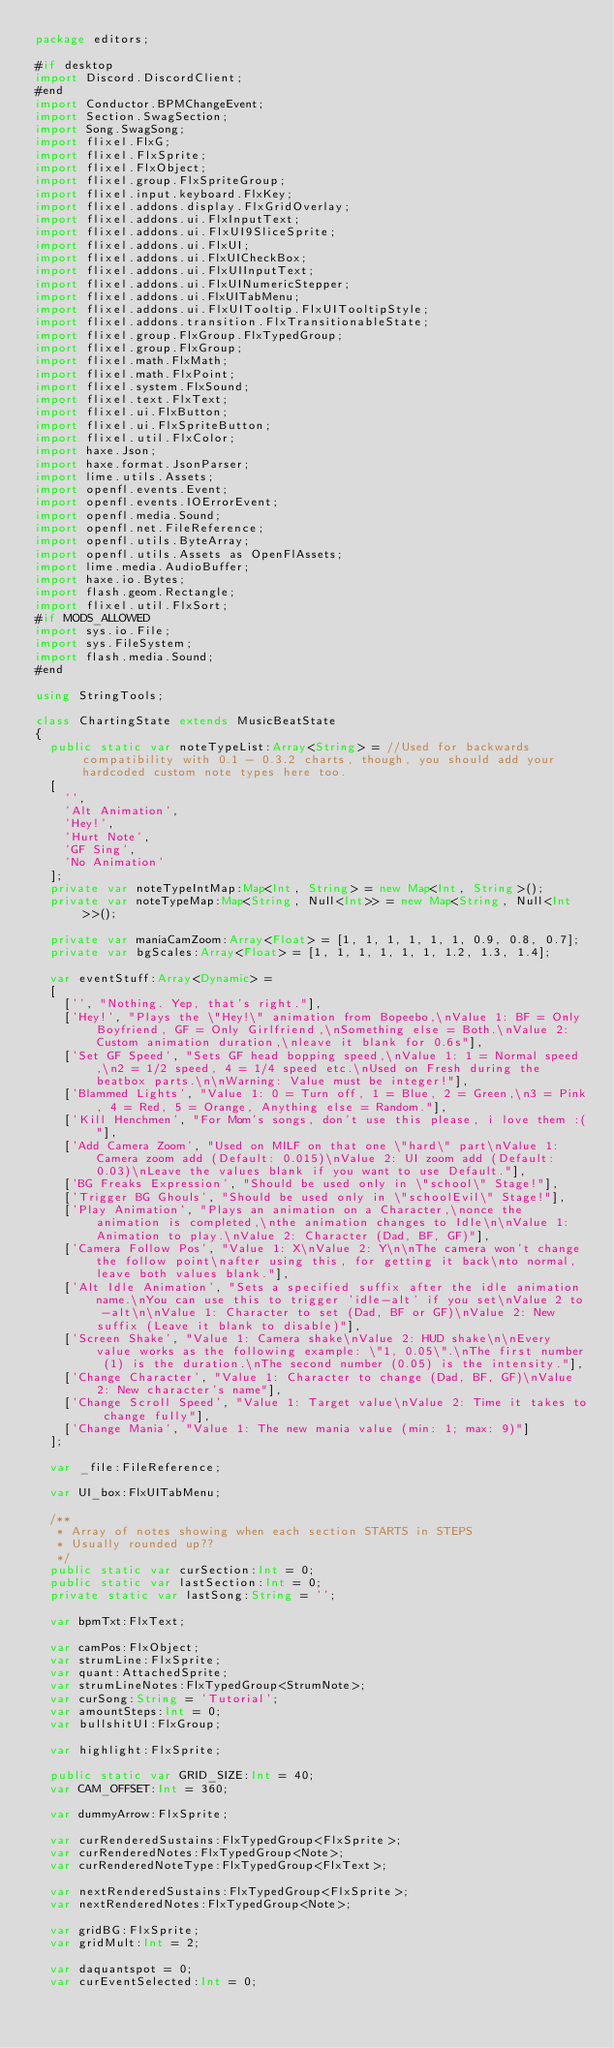Convert code to text. <code><loc_0><loc_0><loc_500><loc_500><_Haxe_>package editors;

#if desktop
import Discord.DiscordClient;
#end
import Conductor.BPMChangeEvent;
import Section.SwagSection;
import Song.SwagSong;
import flixel.FlxG;
import flixel.FlxSprite;
import flixel.FlxObject;
import flixel.group.FlxSpriteGroup;
import flixel.input.keyboard.FlxKey;
import flixel.addons.display.FlxGridOverlay;
import flixel.addons.ui.FlxInputText;
import flixel.addons.ui.FlxUI9SliceSprite;
import flixel.addons.ui.FlxUI;
import flixel.addons.ui.FlxUICheckBox;
import flixel.addons.ui.FlxUIInputText;
import flixel.addons.ui.FlxUINumericStepper;
import flixel.addons.ui.FlxUITabMenu;
import flixel.addons.ui.FlxUITooltip.FlxUITooltipStyle;
import flixel.addons.transition.FlxTransitionableState;
import flixel.group.FlxGroup.FlxTypedGroup;
import flixel.group.FlxGroup;
import flixel.math.FlxMath;
import flixel.math.FlxPoint;
import flixel.system.FlxSound;
import flixel.text.FlxText;
import flixel.ui.FlxButton;
import flixel.ui.FlxSpriteButton;
import flixel.util.FlxColor;
import haxe.Json;
import haxe.format.JsonParser;
import lime.utils.Assets;
import openfl.events.Event;
import openfl.events.IOErrorEvent;
import openfl.media.Sound;
import openfl.net.FileReference;
import openfl.utils.ByteArray;
import openfl.utils.Assets as OpenFlAssets;
import lime.media.AudioBuffer;
import haxe.io.Bytes;
import flash.geom.Rectangle;
import flixel.util.FlxSort;
#if MODS_ALLOWED
import sys.io.File;
import sys.FileSystem;
import flash.media.Sound;
#end

using StringTools;

class ChartingState extends MusicBeatState
{
	public static var noteTypeList:Array<String> = //Used for backwards compatibility with 0.1 - 0.3.2 charts, though, you should add your hardcoded custom note types here too.
	[
		'',
		'Alt Animation',
		'Hey!',
		'Hurt Note',
		'GF Sing',
		'No Animation'
	];
	private var noteTypeIntMap:Map<Int, String> = new Map<Int, String>();
	private var noteTypeMap:Map<String, Null<Int>> = new Map<String, Null<Int>>();

	private var maniaCamZoom:Array<Float> = [1, 1, 1, 1, 1, 1, 0.9, 0.8, 0.7];
	private var bgScales:Array<Float> = [1, 1, 1, 1, 1, 1, 1.2, 1.3, 1.4];

	var eventStuff:Array<Dynamic> =
	[
		['', "Nothing. Yep, that's right."],
		['Hey!', "Plays the \"Hey!\" animation from Bopeebo,\nValue 1: BF = Only Boyfriend, GF = Only Girlfriend,\nSomething else = Both.\nValue 2: Custom animation duration,\nleave it blank for 0.6s"],
		['Set GF Speed', "Sets GF head bopping speed,\nValue 1: 1 = Normal speed,\n2 = 1/2 speed, 4 = 1/4 speed etc.\nUsed on Fresh during the beatbox parts.\n\nWarning: Value must be integer!"],
		['Blammed Lights', "Value 1: 0 = Turn off, 1 = Blue, 2 = Green,\n3 = Pink, 4 = Red, 5 = Orange, Anything else = Random."],
		['Kill Henchmen', "For Mom's songs, don't use this please, i love them :("],
		['Add Camera Zoom', "Used on MILF on that one \"hard\" part\nValue 1: Camera zoom add (Default: 0.015)\nValue 2: UI zoom add (Default: 0.03)\nLeave the values blank if you want to use Default."],
		['BG Freaks Expression', "Should be used only in \"school\" Stage!"],
		['Trigger BG Ghouls', "Should be used only in \"schoolEvil\" Stage!"],
		['Play Animation', "Plays an animation on a Character,\nonce the animation is completed,\nthe animation changes to Idle\n\nValue 1: Animation to play.\nValue 2: Character (Dad, BF, GF)"],
		['Camera Follow Pos', "Value 1: X\nValue 2: Y\n\nThe camera won't change the follow point\nafter using this, for getting it back\nto normal, leave both values blank."],
		['Alt Idle Animation', "Sets a specified suffix after the idle animation name.\nYou can use this to trigger 'idle-alt' if you set\nValue 2 to -alt\n\nValue 1: Character to set (Dad, BF or GF)\nValue 2: New suffix (Leave it blank to disable)"],
		['Screen Shake', "Value 1: Camera shake\nValue 2: HUD shake\n\nEvery value works as the following example: \"1, 0.05\".\nThe first number (1) is the duration.\nThe second number (0.05) is the intensity."],
		['Change Character', "Value 1: Character to change (Dad, BF, GF)\nValue 2: New character's name"],
		['Change Scroll Speed', "Value 1: Target value\nValue 2: Time it takes to change fully"],
		['Change Mania', "Value 1: The new mania value (min: 1; max: 9)"]
	];

	var _file:FileReference;

	var UI_box:FlxUITabMenu;

	/**
	 * Array of notes showing when each section STARTS in STEPS
	 * Usually rounded up??
	 */
	public static var curSection:Int = 0;
	public static var lastSection:Int = 0;
	private static var lastSong:String = '';

	var bpmTxt:FlxText;

	var camPos:FlxObject;
	var strumLine:FlxSprite;
	var quant:AttachedSprite;
	var strumLineNotes:FlxTypedGroup<StrumNote>;
	var curSong:String = 'Tutorial';
	var amountSteps:Int = 0;
	var bullshitUI:FlxGroup;

	var highlight:FlxSprite;

	public static var GRID_SIZE:Int = 40;
	var CAM_OFFSET:Int = 360;

	var dummyArrow:FlxSprite;

	var curRenderedSustains:FlxTypedGroup<FlxSprite>;
	var curRenderedNotes:FlxTypedGroup<Note>;
	var curRenderedNoteType:FlxTypedGroup<FlxText>;

	var nextRenderedSustains:FlxTypedGroup<FlxSprite>;
	var nextRenderedNotes:FlxTypedGroup<Note>;

	var gridBG:FlxSprite;
	var gridMult:Int = 2;

	var daquantspot = 0;
	var curEventSelected:Int = 0;
	</code> 